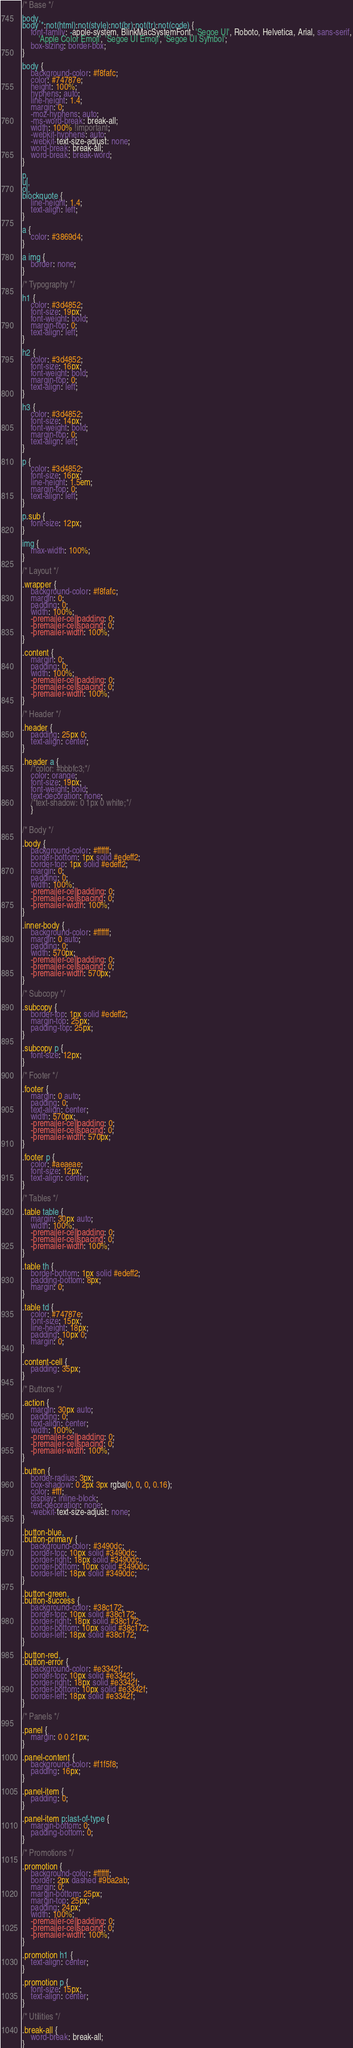Convert code to text. <code><loc_0><loc_0><loc_500><loc_500><_CSS_>/* Base */

body,
body *:not(html):not(style):not(br):not(tr):not(code) {
    font-family: -apple-system, BlinkMacSystemFont, 'Segoe UI', Roboto, Helvetica, Arial, sans-serif,
        'Apple Color Emoji', 'Segoe UI Emoji', 'Segoe UI Symbol';
    box-sizing: border-box;
}

body {
    background-color: #f8fafc;
    color: #74787e;
    height: 100%;
    hyphens: auto;
    line-height: 1.4;
    margin: 0;
    -moz-hyphens: auto;
    -ms-word-break: break-all;
    width: 100% !important;
    -webkit-hyphens: auto;
    -webkit-text-size-adjust: none;
    word-break: break-all;
    word-break: break-word;
}

p,
ul,
ol,
blockquote {
    line-height: 1.4;
    text-align: left;
}

a {
    color: #3869d4;
}

a img {
    border: none;
}

/* Typography */

h1 {
    color: #3d4852;
    font-size: 19px;
    font-weight: bold;
    margin-top: 0;
    text-align: left;
}

h2 {
    color: #3d4852;
    font-size: 16px;
    font-weight: bold;
    margin-top: 0;
    text-align: left;
}

h3 {
    color: #3d4852;
    font-size: 14px;
    font-weight: bold;
    margin-top: 0;
    text-align: left;
}

p {
    color: #3d4852;
    font-size: 16px;
    line-height: 1.5em;
    margin-top: 0;
    text-align: left;
}

p.sub {
    font-size: 12px;
}

img {
    max-width: 100%;
}

/* Layout */

.wrapper {
    background-color: #f8fafc;
    margin: 0;
    padding: 0;
    width: 100%;
    -premailer-cellpadding: 0;
    -premailer-cellspacing: 0;
    -premailer-width: 100%;
}

.content {
    margin: 0;
    padding: 0;
    width: 100%;
    -premailer-cellpadding: 0;
    -premailer-cellspacing: 0;
    -premailer-width: 100%;
}

/* Header */

.header {
    padding: 25px 0;
    text-align: center;
}

.header a {
    /*color: #bbbfc3;*/
    color: orange;
    font-size: 19px;
    font-weight: bold;
    text-decoration: none;
    /*text-shadow: 0 1px 0 white;*/
    }
    

/* Body */

.body {
    background-color: #ffffff;
    border-bottom: 1px solid #edeff2;
    border-top: 1px solid #edeff2;
    margin: 0;
    padding: 0;
    width: 100%;
    -premailer-cellpadding: 0;
    -premailer-cellspacing: 0;
    -premailer-width: 100%;
}

.inner-body {
    background-color: #ffffff;
    margin: 0 auto;
    padding: 0;
    width: 570px;
    -premailer-cellpadding: 0;
    -premailer-cellspacing: 0;
    -premailer-width: 570px;
}

/* Subcopy */

.subcopy {
    border-top: 1px solid #edeff2;
    margin-top: 25px;
    padding-top: 25px;
}

.subcopy p {
    font-size: 12px;
}

/* Footer */

.footer {
    margin: 0 auto;
    padding: 0;
    text-align: center;
    width: 570px;
    -premailer-cellpadding: 0;
    -premailer-cellspacing: 0;
    -premailer-width: 570px;
}

.footer p {
    color: #aeaeae;
    font-size: 12px;
    text-align: center;
}

/* Tables */

.table table {
    margin: 30px auto;
    width: 100%;
    -premailer-cellpadding: 0;
    -premailer-cellspacing: 0;
    -premailer-width: 100%;
}

.table th {
    border-bottom: 1px solid #edeff2;
    padding-bottom: 8px;
    margin: 0;
}

.table td {
    color: #74787e;
    font-size: 15px;
    line-height: 18px;
    padding: 10px 0;
    margin: 0;
}

.content-cell {
    padding: 35px;
}

/* Buttons */

.action {
    margin: 30px auto;
    padding: 0;
    text-align: center;
    width: 100%;
    -premailer-cellpadding: 0;
    -premailer-cellspacing: 0;
    -premailer-width: 100%;
}

.button {
    border-radius: 3px;
    box-shadow: 0 2px 3px rgba(0, 0, 0, 0.16);
    color: #fff;
    display: inline-block;
    text-decoration: none;
    -webkit-text-size-adjust: none;
}

.button-blue,
.button-primary {
    background-color: #3490dc;
    border-top: 10px solid #3490dc;
    border-right: 18px solid #3490dc;
    border-bottom: 10px solid #3490dc;
    border-left: 18px solid #3490dc;
}

.button-green,
.button-success {
    background-color: #38c172;
    border-top: 10px solid #38c172;
    border-right: 18px solid #38c172;
    border-bottom: 10px solid #38c172;
    border-left: 18px solid #38c172;
}

.button-red,
.button-error {
    background-color: #e3342f;
    border-top: 10px solid #e3342f;
    border-right: 18px solid #e3342f;
    border-bottom: 10px solid #e3342f;
    border-left: 18px solid #e3342f;
}

/* Panels */

.panel {
    margin: 0 0 21px;
}

.panel-content {
    background-color: #f1f5f8;
    padding: 16px;
}

.panel-item {
    padding: 0;
}

.panel-item p:last-of-type {
    margin-bottom: 0;
    padding-bottom: 0;
}

/* Promotions */

.promotion {
    background-color: #ffffff;
    border: 2px dashed #9ba2ab;
    margin: 0;
    margin-bottom: 25px;
    margin-top: 25px;
    padding: 24px;
    width: 100%;
    -premailer-cellpadding: 0;
    -premailer-cellspacing: 0;
    -premailer-width: 100%;
}

.promotion h1 {
    text-align: center;
}

.promotion p {
    font-size: 15px;
    text-align: center;
}

/* Utilities */

.break-all {
    word-break: break-all;
}</code> 